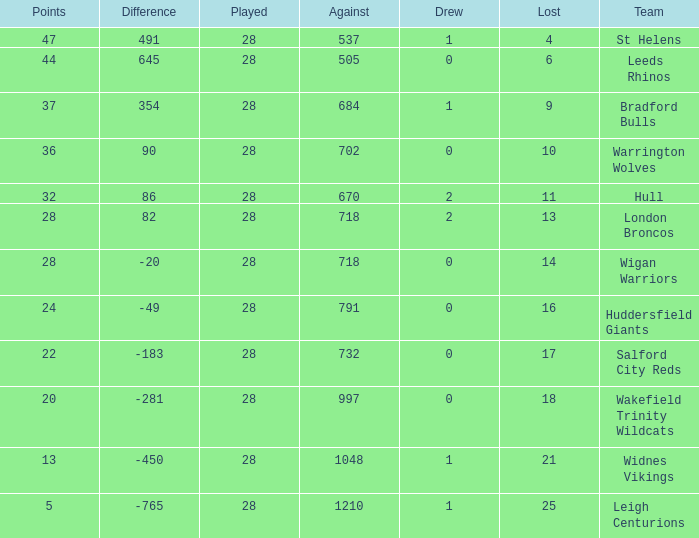What is the highest difference for the team that had less than 0 draws? None. 